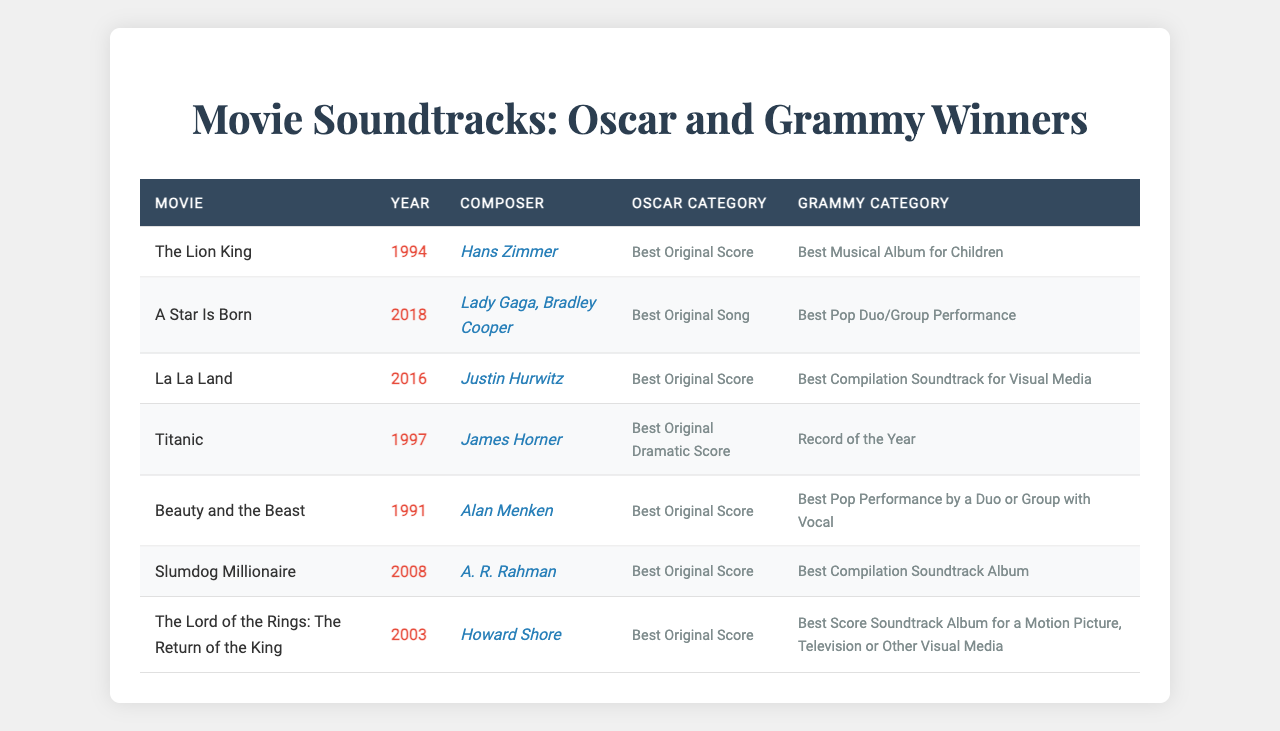What is the movie released in 1994 that won both an Oscar and a Grammy? From the table, we can see that "The Lion King," released in 1994, is listed with both an Oscar for Best Original Score and a Grammy for Best Musical Album for Children.
Answer: The Lion King Who composed the soundtrack for "Titanic"? By looking at the entry for "Titanic" in the table, we find that it was composed by James Horner, as indicated in the composer column.
Answer: James Horner How many soundtracks listed won the Grammy award for "Best Compilation Soundtrack for Visual Media"? The table shows only one soundtrack, "La La Land," that won the Grammy for Best Compilation Soundtrack for Visual Media, confirming that it is the sole entry under that category.
Answer: 1 Which soundtrack features the Grammy category "Record of the Year"? Referring to the table, it is clear that "Titanic" is listed under the Grammy category "Record of the Year."
Answer: Titanic What is the average year of release for the soundtracks in this table? To find the average, we first sum the years: 1994 + 2018 + 2016 + 1997 + 1991 + 2008 + 2003 = 1397. There are 7 soundtracks, so we divide: 1397 / 7 = 199.57. Rounding gives us 1995 (considering the closest whole number).
Answer: 1995 Did "A Star Is Born" win an Oscar for Best Original Score? Looking specifically at "A Star Is Born," we see it won an Oscar for Best Original Song instead of Best Original Score, making the statement false.
Answer: No Which two soundtracks won an Oscar for Best Original Score? From the table, the soundtracks "The Lion King," "La La Land," "Slumdog Millionaire," and "The Lord of the Rings: The Return of the King" are all noted for winning the Oscar for Best Original Score. These represent four soundtracks.
Answer: 4 How many soundtracks in the list won both specific awards in 2008 or later? Only "A Star Is Born" (2018) and "Slumdog Millionaire" (2008) won both an Oscar and Grammy as per the table. Counting these gives us a total of 2 soundtracks.
Answer: 2 What is the most recent movie soundtrack that won both an Oscar and a Grammy? Referring to the years listed, "A Star Is Born" (2018) is the most recent soundtrack, confirming it as the latest winner of both awards.
Answer: A Star Is Born Is there any soundtrack that won both awards for a category related to children's music? Checking the table, "The Lion King" is the only soundtrack that won both an Oscar and Grammy specifically for categories aimed at children's music, confirming its uniqueness in this aspect within the table.
Answer: Yes 